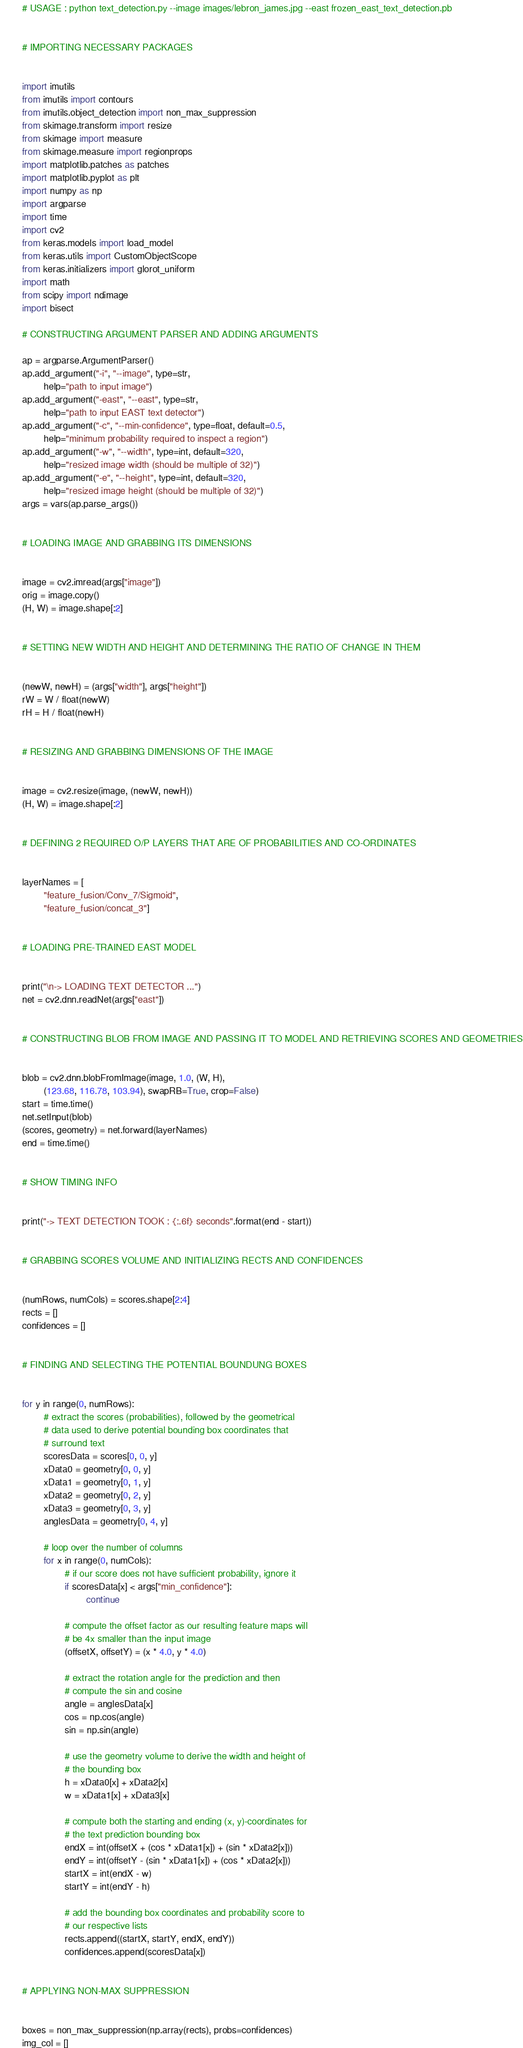Convert code to text. <code><loc_0><loc_0><loc_500><loc_500><_Python_># USAGE : python text_detection.py --image images/lebron_james.jpg --east frozen_east_text_detection.pb


# IMPORTING NECESSARY PACKAGES


import imutils
from imutils import contours
from imutils.object_detection import non_max_suppression
from skimage.transform import resize
from skimage import measure
from skimage.measure import regionprops
import matplotlib.patches as patches
import matplotlib.pyplot as plt
import numpy as np
import argparse
import time
import cv2
from keras.models import load_model
from keras.utils import CustomObjectScope
from keras.initializers import glorot_uniform
import math
from scipy import ndimage
import bisect

# CONSTRUCTING ARGUMENT PARSER AND ADDING ARGUMENTS

ap = argparse.ArgumentParser()
ap.add_argument("-i", "--image", type=str,
        help="path to input image")
ap.add_argument("-east", "--east", type=str,
        help="path to input EAST text detector")
ap.add_argument("-c", "--min-confidence", type=float, default=0.5,
        help="minimum probability required to inspect a region")
ap.add_argument("-w", "--width", type=int, default=320,
        help="resized image width (should be multiple of 32)")
ap.add_argument("-e", "--height", type=int, default=320,
        help="resized image height (should be multiple of 32)")
args = vars(ap.parse_args())


# LOADING IMAGE AND GRABBING ITS DIMENSIONS


image = cv2.imread(args["image"])
orig = image.copy()
(H, W) = image.shape[:2]


# SETTING NEW WIDTH AND HEIGHT AND DETERMINING THE RATIO OF CHANGE IN THEM


(newW, newH) = (args["width"], args["height"])
rW = W / float(newW)
rH = H / float(newH)


# RESIZING AND GRABBING DIMENSIONS OF THE IMAGE


image = cv2.resize(image, (newW, newH))
(H, W) = image.shape[:2]


# DEFINING 2 REQUIRED O/P LAYERS THAT ARE OF PROBABILITIES AND CO-ORDINATES


layerNames = [
        "feature_fusion/Conv_7/Sigmoid",
        "feature_fusion/concat_3"]


# LOADING PRE-TRAINED EAST MODEL


print("\n-> LOADING TEXT DETECTOR ...")
net = cv2.dnn.readNet(args["east"])


# CONSTRUCTING BLOB FROM IMAGE AND PASSING IT TO MODEL AND RETRIEVING SCORES AND GEOMETRIES


blob = cv2.dnn.blobFromImage(image, 1.0, (W, H),
        (123.68, 116.78, 103.94), swapRB=True, crop=False)
start = time.time()
net.setInput(blob)
(scores, geometry) = net.forward(layerNames)
end = time.time()


# SHOW TIMING INFO


print("-> TEXT DETECTION TOOK : {:.6f} seconds".format(end - start))


# GRABBING SCORES VOLUME AND INITIALIZING RECTS AND CONFIDENCES


(numRows, numCols) = scores.shape[2:4]
rects = []
confidences = []


# FINDING AND SELECTING THE POTENTIAL BOUNDUNG BOXES


for y in range(0, numRows):
        # extract the scores (probabilities), followed by the geometrical
        # data used to derive potential bounding box coordinates that
        # surround text
        scoresData = scores[0, 0, y]
        xData0 = geometry[0, 0, y]
        xData1 = geometry[0, 1, y]
        xData2 = geometry[0, 2, y]
        xData3 = geometry[0, 3, y]
        anglesData = geometry[0, 4, y]

        # loop over the number of columns
        for x in range(0, numCols):
                # if our score does not have sufficient probability, ignore it
                if scoresData[x] < args["min_confidence"]:
                        continue

                # compute the offset factor as our resulting feature maps will
                # be 4x smaller than the input image
                (offsetX, offsetY) = (x * 4.0, y * 4.0)

                # extract the rotation angle for the prediction and then
                # compute the sin and cosine
                angle = anglesData[x]
                cos = np.cos(angle)
                sin = np.sin(angle)

                # use the geometry volume to derive the width and height of
                # the bounding box
                h = xData0[x] + xData2[x]
                w = xData1[x] + xData3[x]

                # compute both the starting and ending (x, y)-coordinates for
                # the text prediction bounding box
                endX = int(offsetX + (cos * xData1[x]) + (sin * xData2[x]))
                endY = int(offsetY - (sin * xData1[x]) + (cos * xData2[x]))
                startX = int(endX - w)
                startY = int(endY - h)

                # add the bounding box coordinates and probability score to
                # our respective lists
                rects.append((startX, startY, endX, endY))
                confidences.append(scoresData[x])


# APPLYING NON-MAX SUPPRESSION


boxes = non_max_suppression(np.array(rects), probs=confidences)
img_col = []
</code> 